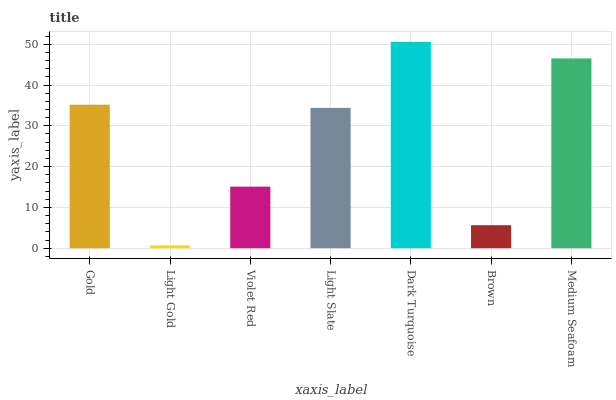Is Light Gold the minimum?
Answer yes or no. Yes. Is Dark Turquoise the maximum?
Answer yes or no. Yes. Is Violet Red the minimum?
Answer yes or no. No. Is Violet Red the maximum?
Answer yes or no. No. Is Violet Red greater than Light Gold?
Answer yes or no. Yes. Is Light Gold less than Violet Red?
Answer yes or no. Yes. Is Light Gold greater than Violet Red?
Answer yes or no. No. Is Violet Red less than Light Gold?
Answer yes or no. No. Is Light Slate the high median?
Answer yes or no. Yes. Is Light Slate the low median?
Answer yes or no. Yes. Is Violet Red the high median?
Answer yes or no. No. Is Dark Turquoise the low median?
Answer yes or no. No. 